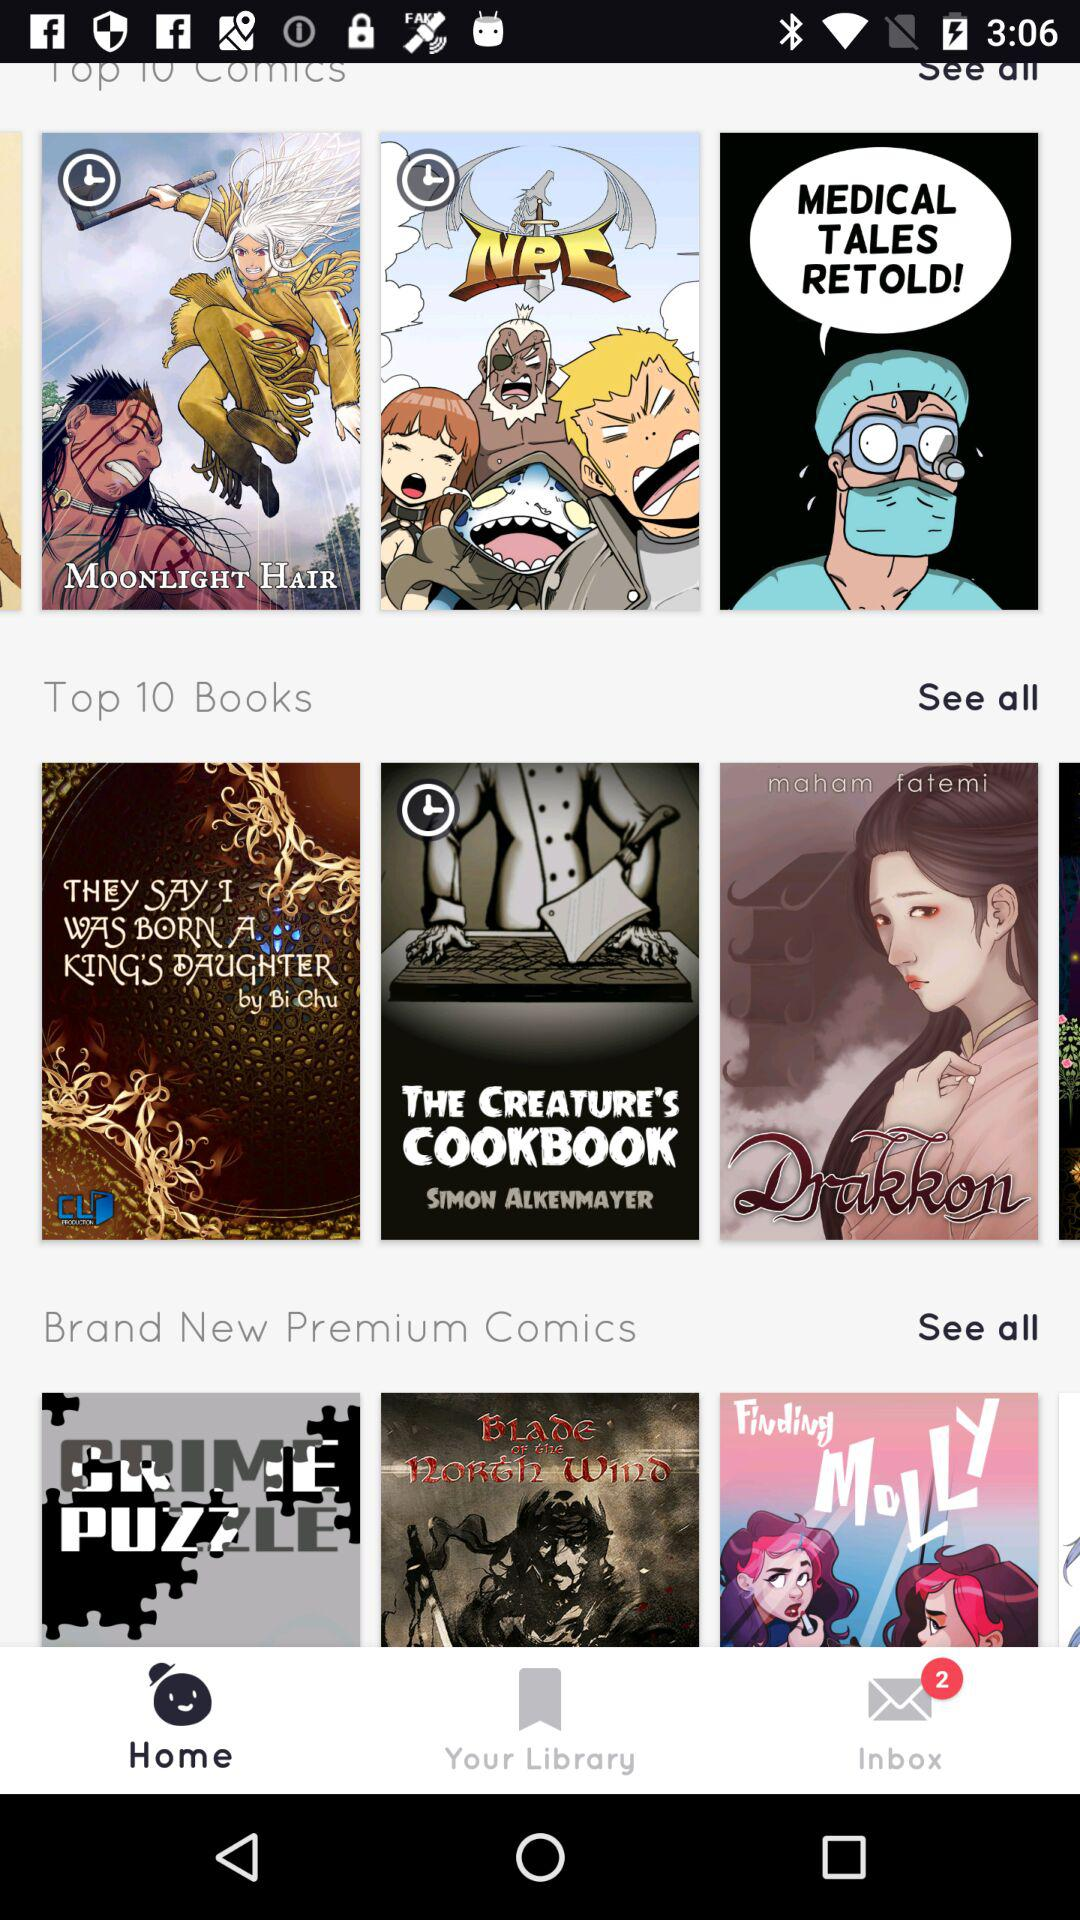How many new messages are in the inbox? There are 2 new messages in the inbox. 